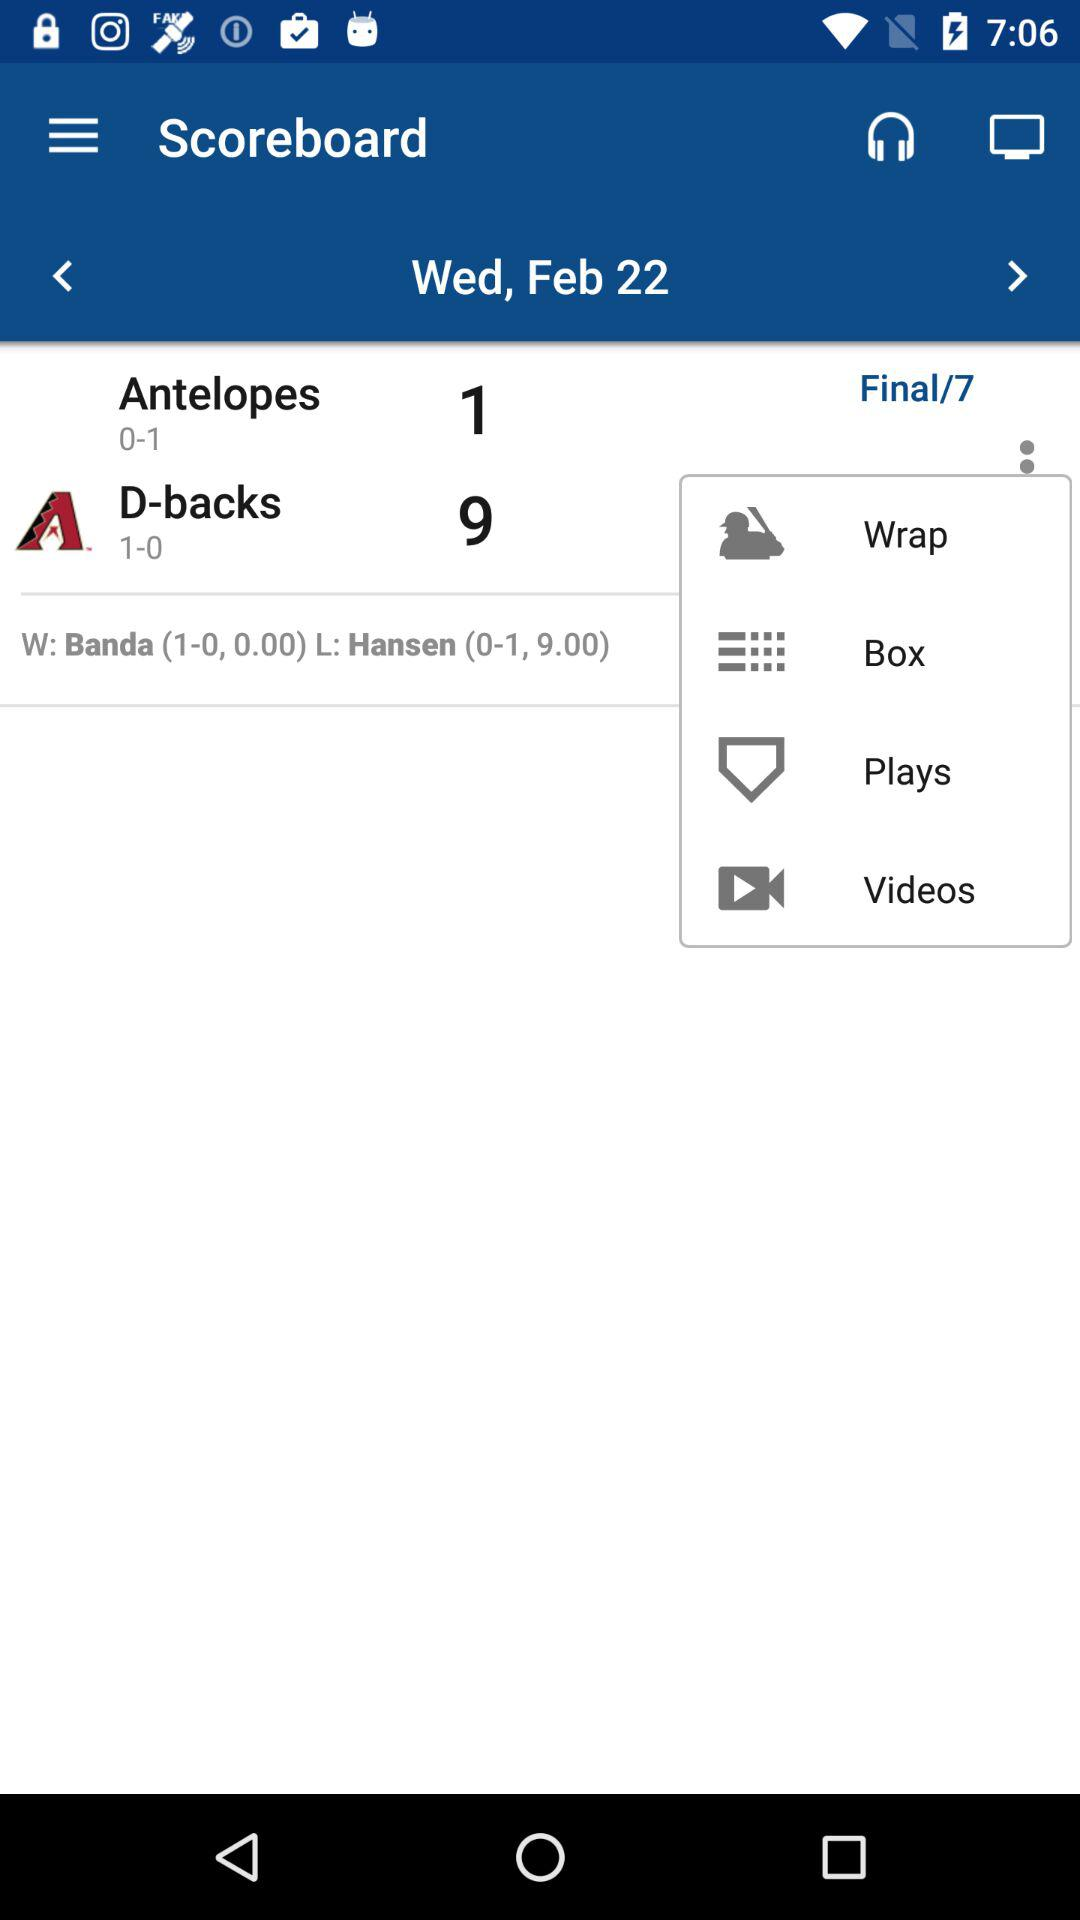How many plays were there?
When the provided information is insufficient, respond with <no answer>. <no answer> 